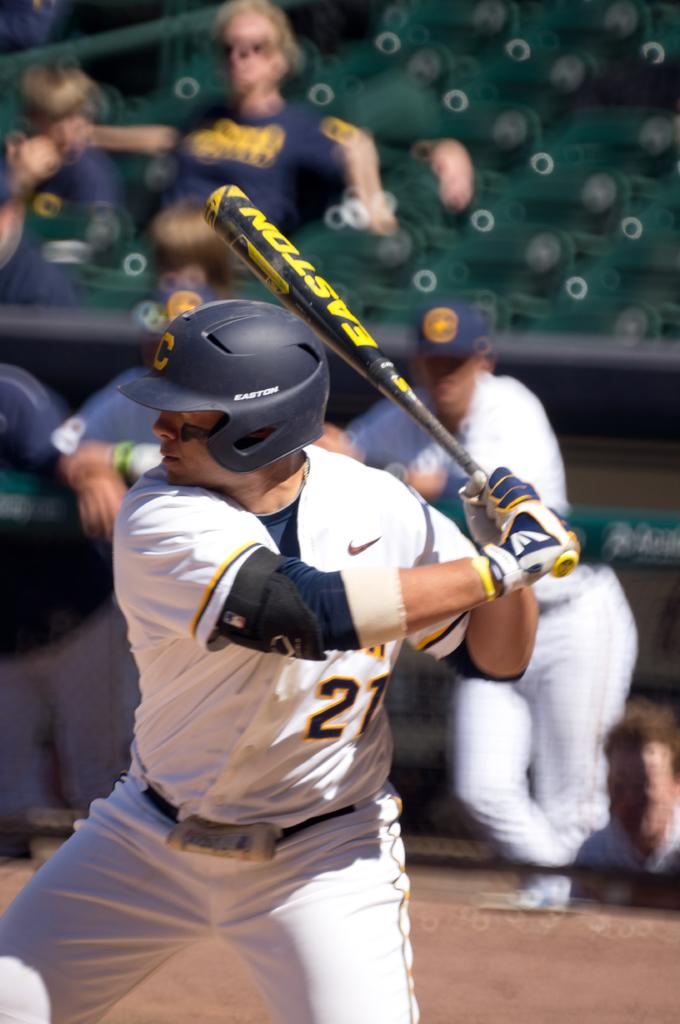How many people are in the image? There are people in the image, but the exact number is not specified. What is the person wearing a helmet holding? The person with the helmet is holding an object. What can be seen beneath the people in the image? The ground is visible in the image. How would you describe the background of the image? The background of the image is blurred. How many pizzas are on the bed in the image? There is no mention of pizzas or a bed in the image, so it is not possible to answer this question. 